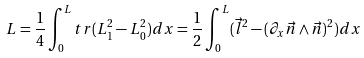<formula> <loc_0><loc_0><loc_500><loc_500>L = \frac { 1 } { 4 } \int _ { 0 } ^ { L } t r ( L _ { 1 } ^ { 2 } - L _ { 0 } ^ { 2 } ) d x = \frac { 1 } { 2 } \int _ { 0 } ^ { L } ( \vec { l } ^ { 2 } - ( \partial _ { x } \vec { n } \wedge \vec { n } ) ^ { 2 } ) d x</formula> 